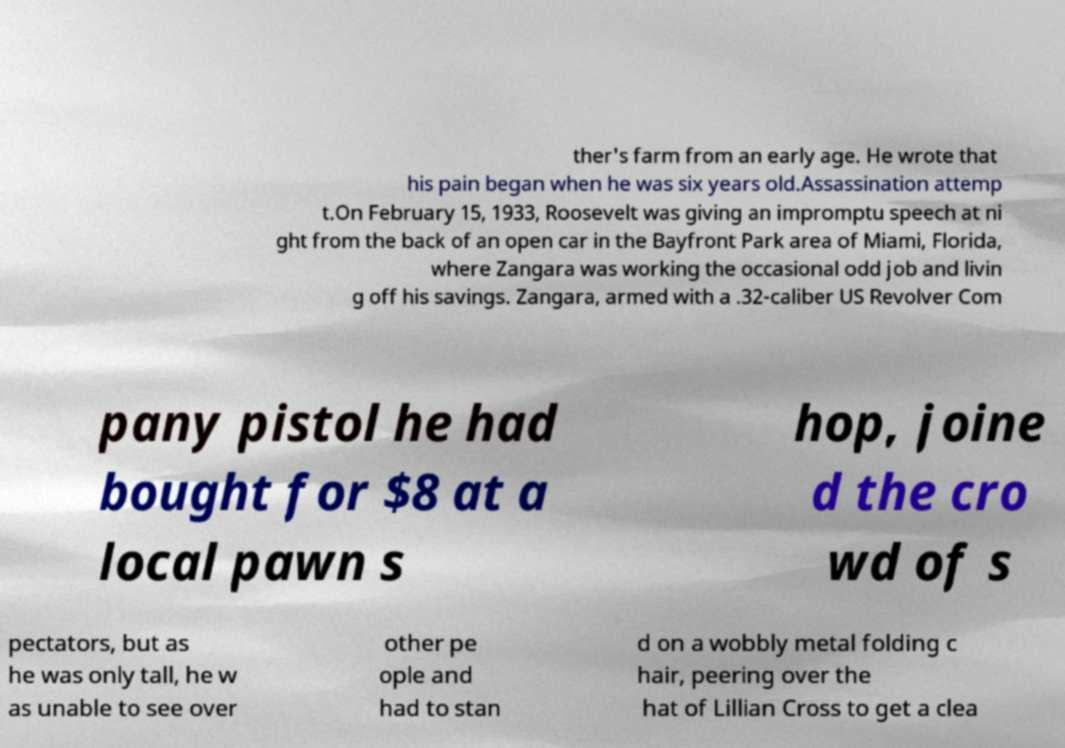Could you extract and type out the text from this image? ther's farm from an early age. He wrote that his pain began when he was six years old.Assassination attemp t.On February 15, 1933, Roosevelt was giving an impromptu speech at ni ght from the back of an open car in the Bayfront Park area of Miami, Florida, where Zangara was working the occasional odd job and livin g off his savings. Zangara, armed with a .32-caliber US Revolver Com pany pistol he had bought for $8 at a local pawn s hop, joine d the cro wd of s pectators, but as he was only tall, he w as unable to see over other pe ople and had to stan d on a wobbly metal folding c hair, peering over the hat of Lillian Cross to get a clea 